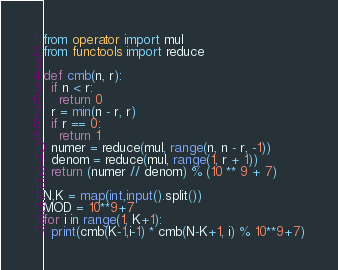<code> <loc_0><loc_0><loc_500><loc_500><_Python_>from operator import mul
from functools import reduce

def cmb(n, r):
  if n < r:
    return 0
  r = min(n - r, r)
  if r == 0:
    return 1
  numer = reduce(mul, range(n, n - r, -1))
  denom = reduce(mul, range(1, r + 1))
  return (numer // denom) % (10 ** 9 + 7)

N,K = map(int,input().split())
MOD = 10**9+7
for i in range(1, K+1):
  print(cmb(K-1,i-1) * cmb(N-K+1, i) % 10**9+7)</code> 